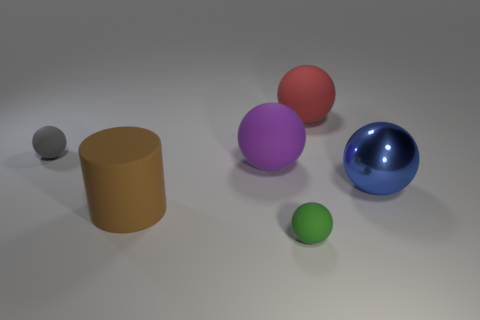Subtract all yellow balls. Subtract all cyan cylinders. How many balls are left? 5 Add 2 tiny green cylinders. How many objects exist? 8 Subtract all balls. How many objects are left? 1 Add 4 small green matte things. How many small green matte things are left? 5 Add 3 big brown shiny balls. How many big brown shiny balls exist? 3 Subtract 0 brown balls. How many objects are left? 6 Subtract all big brown rubber cylinders. Subtract all large brown cylinders. How many objects are left? 4 